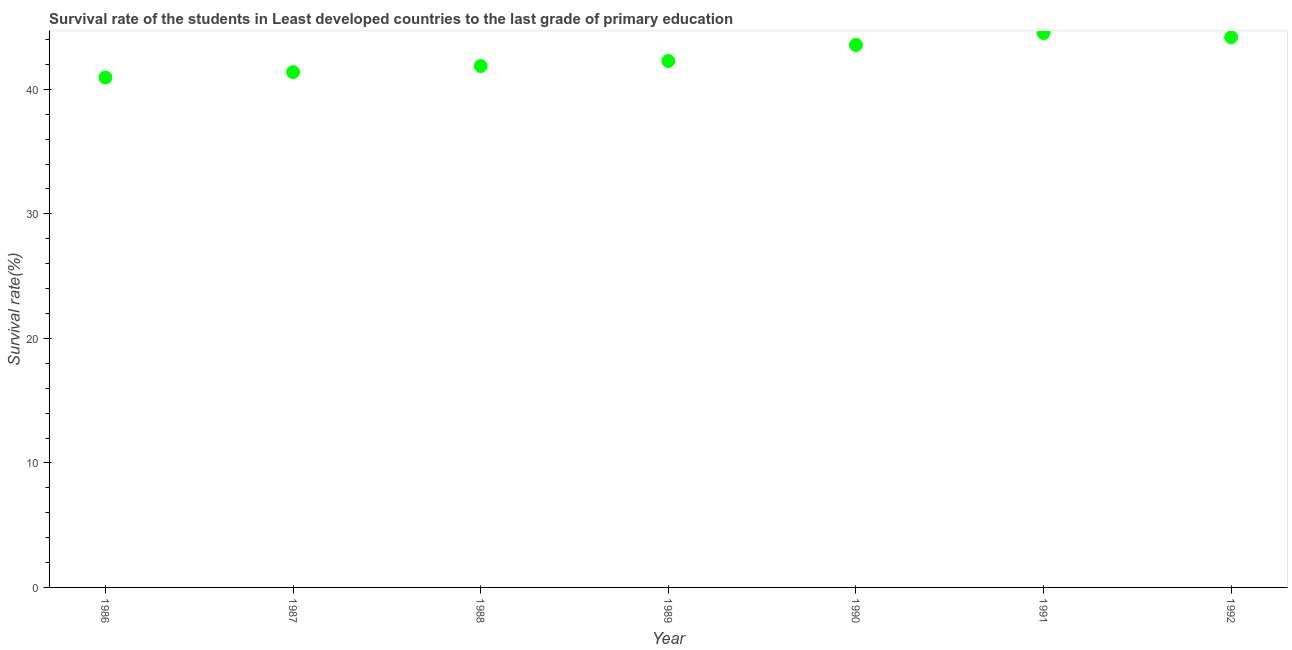What is the survival rate in primary education in 1990?
Keep it short and to the point. 43.56. Across all years, what is the maximum survival rate in primary education?
Keep it short and to the point. 44.52. Across all years, what is the minimum survival rate in primary education?
Ensure brevity in your answer.  40.95. In which year was the survival rate in primary education maximum?
Your response must be concise. 1991. In which year was the survival rate in primary education minimum?
Offer a very short reply. 1986. What is the sum of the survival rate in primary education?
Provide a succinct answer. 298.76. What is the difference between the survival rate in primary education in 1986 and 1989?
Ensure brevity in your answer.  -1.33. What is the average survival rate in primary education per year?
Your response must be concise. 42.68. What is the median survival rate in primary education?
Provide a short and direct response. 42.28. What is the ratio of the survival rate in primary education in 1989 to that in 1991?
Give a very brief answer. 0.95. Is the difference between the survival rate in primary education in 1987 and 1991 greater than the difference between any two years?
Give a very brief answer. No. What is the difference between the highest and the second highest survival rate in primary education?
Offer a terse response. 0.33. What is the difference between the highest and the lowest survival rate in primary education?
Make the answer very short. 3.58. In how many years, is the survival rate in primary education greater than the average survival rate in primary education taken over all years?
Your response must be concise. 3. Does the survival rate in primary education monotonically increase over the years?
Offer a very short reply. No. What is the difference between two consecutive major ticks on the Y-axis?
Keep it short and to the point. 10. Are the values on the major ticks of Y-axis written in scientific E-notation?
Give a very brief answer. No. Does the graph contain any zero values?
Keep it short and to the point. No. Does the graph contain grids?
Offer a very short reply. No. What is the title of the graph?
Make the answer very short. Survival rate of the students in Least developed countries to the last grade of primary education. What is the label or title of the Y-axis?
Ensure brevity in your answer.  Survival rate(%). What is the Survival rate(%) in 1986?
Provide a short and direct response. 40.95. What is the Survival rate(%) in 1987?
Provide a short and direct response. 41.38. What is the Survival rate(%) in 1988?
Your answer should be compact. 41.88. What is the Survival rate(%) in 1989?
Make the answer very short. 42.28. What is the Survival rate(%) in 1990?
Your answer should be very brief. 43.56. What is the Survival rate(%) in 1991?
Ensure brevity in your answer.  44.52. What is the Survival rate(%) in 1992?
Keep it short and to the point. 44.19. What is the difference between the Survival rate(%) in 1986 and 1987?
Make the answer very short. -0.44. What is the difference between the Survival rate(%) in 1986 and 1988?
Offer a terse response. -0.93. What is the difference between the Survival rate(%) in 1986 and 1989?
Keep it short and to the point. -1.33. What is the difference between the Survival rate(%) in 1986 and 1990?
Provide a short and direct response. -2.62. What is the difference between the Survival rate(%) in 1986 and 1991?
Ensure brevity in your answer.  -3.58. What is the difference between the Survival rate(%) in 1986 and 1992?
Your response must be concise. -3.24. What is the difference between the Survival rate(%) in 1987 and 1988?
Your response must be concise. -0.49. What is the difference between the Survival rate(%) in 1987 and 1989?
Your answer should be compact. -0.89. What is the difference between the Survival rate(%) in 1987 and 1990?
Ensure brevity in your answer.  -2.18. What is the difference between the Survival rate(%) in 1987 and 1991?
Provide a short and direct response. -3.14. What is the difference between the Survival rate(%) in 1987 and 1992?
Keep it short and to the point. -2.81. What is the difference between the Survival rate(%) in 1988 and 1989?
Your response must be concise. -0.4. What is the difference between the Survival rate(%) in 1988 and 1990?
Your answer should be compact. -1.69. What is the difference between the Survival rate(%) in 1988 and 1991?
Give a very brief answer. -2.65. What is the difference between the Survival rate(%) in 1988 and 1992?
Give a very brief answer. -2.31. What is the difference between the Survival rate(%) in 1989 and 1990?
Offer a very short reply. -1.29. What is the difference between the Survival rate(%) in 1989 and 1991?
Make the answer very short. -2.25. What is the difference between the Survival rate(%) in 1989 and 1992?
Your answer should be very brief. -1.91. What is the difference between the Survival rate(%) in 1990 and 1991?
Provide a short and direct response. -0.96. What is the difference between the Survival rate(%) in 1990 and 1992?
Provide a short and direct response. -0.63. What is the difference between the Survival rate(%) in 1991 and 1992?
Provide a succinct answer. 0.33. What is the ratio of the Survival rate(%) in 1986 to that in 1987?
Provide a succinct answer. 0.99. What is the ratio of the Survival rate(%) in 1986 to that in 1988?
Offer a very short reply. 0.98. What is the ratio of the Survival rate(%) in 1986 to that in 1990?
Ensure brevity in your answer.  0.94. What is the ratio of the Survival rate(%) in 1986 to that in 1992?
Ensure brevity in your answer.  0.93. What is the ratio of the Survival rate(%) in 1987 to that in 1992?
Offer a terse response. 0.94. What is the ratio of the Survival rate(%) in 1988 to that in 1991?
Make the answer very short. 0.94. What is the ratio of the Survival rate(%) in 1988 to that in 1992?
Ensure brevity in your answer.  0.95. What is the ratio of the Survival rate(%) in 1989 to that in 1990?
Give a very brief answer. 0.97. What is the ratio of the Survival rate(%) in 1989 to that in 1992?
Ensure brevity in your answer.  0.96. 